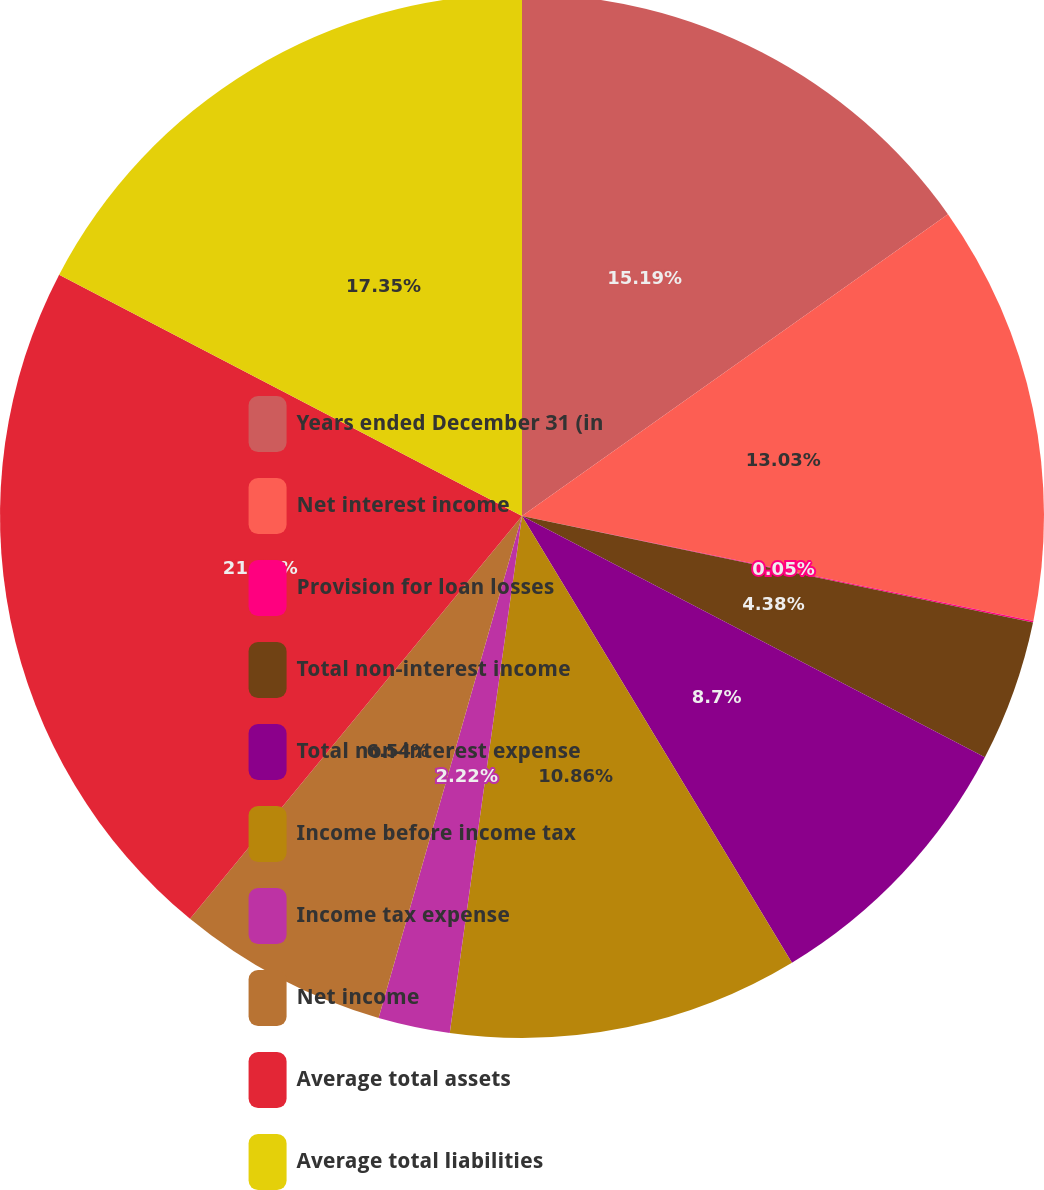<chart> <loc_0><loc_0><loc_500><loc_500><pie_chart><fcel>Years ended December 31 (in<fcel>Net interest income<fcel>Provision for loan losses<fcel>Total non-interest income<fcel>Total non-interest expense<fcel>Income before income tax<fcel>Income tax expense<fcel>Net income<fcel>Average total assets<fcel>Average total liabilities<nl><fcel>15.19%<fcel>13.03%<fcel>0.05%<fcel>4.38%<fcel>8.7%<fcel>10.86%<fcel>2.22%<fcel>6.54%<fcel>21.68%<fcel>17.35%<nl></chart> 